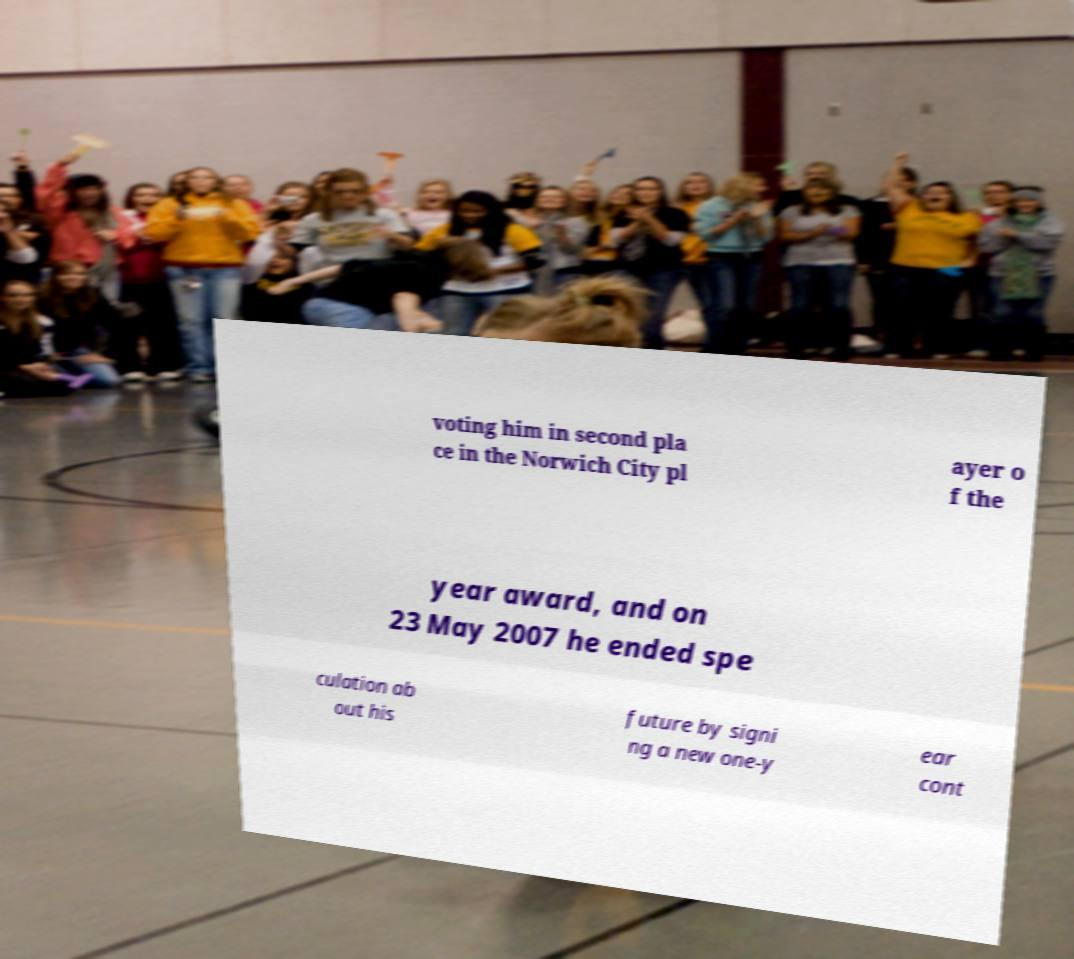Please identify and transcribe the text found in this image. voting him in second pla ce in the Norwich City pl ayer o f the year award, and on 23 May 2007 he ended spe culation ab out his future by signi ng a new one-y ear cont 